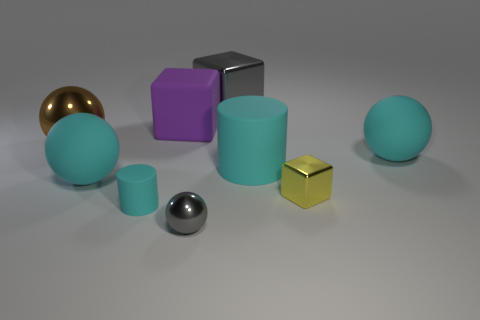There is a object in front of the cylinder that is in front of the yellow cube; what shape is it?
Provide a short and direct response. Sphere. Are there any small yellow metallic objects that are behind the big metal thing right of the metallic sphere that is behind the gray metallic ball?
Provide a succinct answer. No. There is a large purple object; are there any large balls behind it?
Your answer should be compact. No. How many small cylinders are the same color as the large metallic sphere?
Keep it short and to the point. 0. What size is the purple object that is the same material as the small cyan object?
Your response must be concise. Large. There is a rubber cylinder that is to the right of the small thing that is in front of the matte cylinder to the left of the big purple block; how big is it?
Your response must be concise. Large. There is a cyan rubber sphere on the right side of the small cyan rubber cylinder; what is its size?
Make the answer very short. Large. What number of purple objects are either tiny metal cylinders or tiny shiny balls?
Make the answer very short. 0. Are there any gray spheres of the same size as the purple object?
Keep it short and to the point. No. What is the material of the brown sphere that is the same size as the gray block?
Offer a terse response. Metal. 